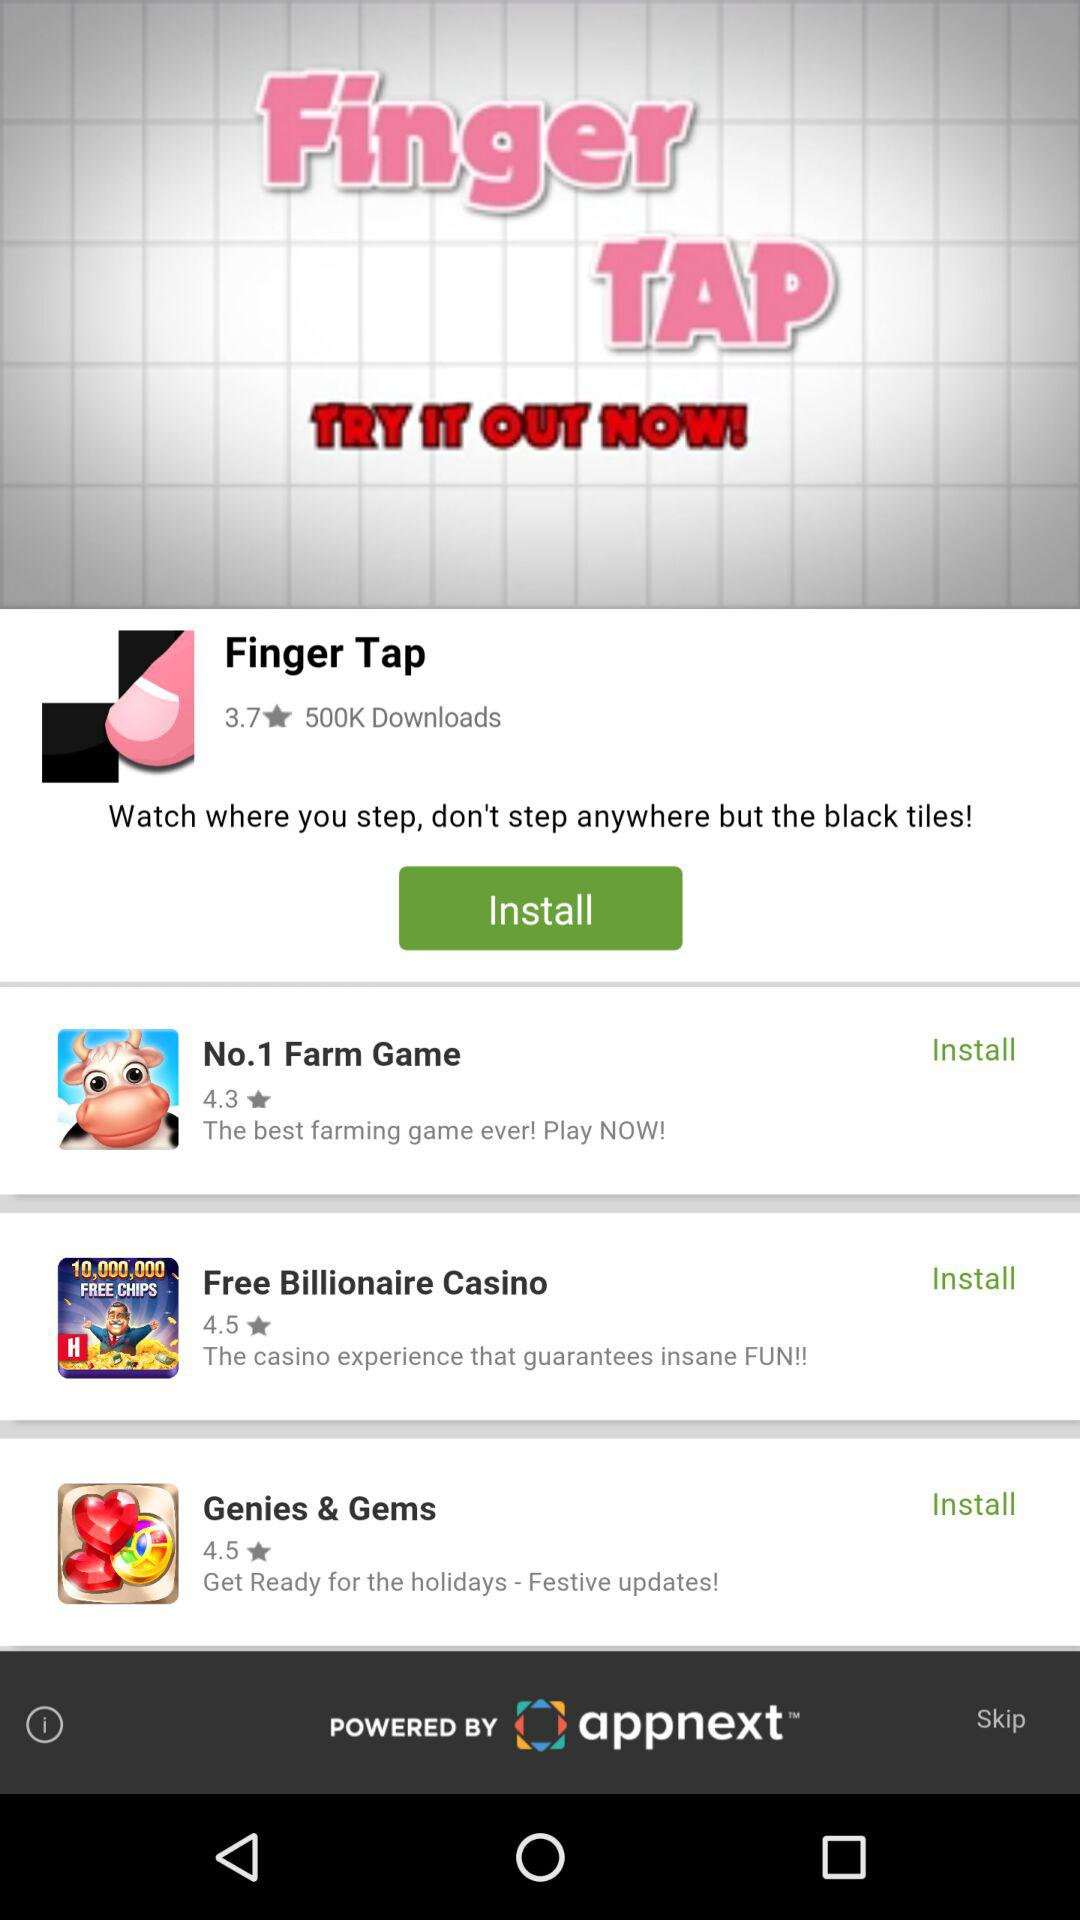What's the rating for "Finger Tap"? The rating is 3.7 stars. 